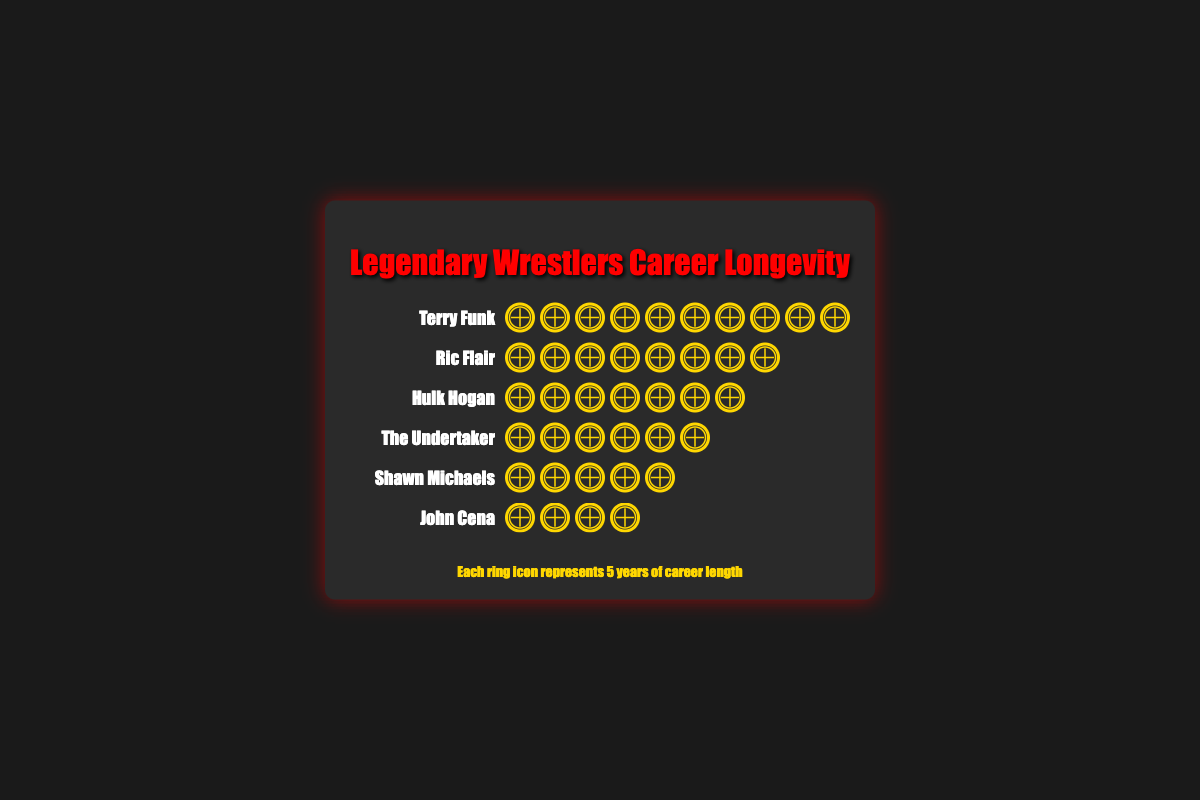Which wrestler has the longest career according to the figure? Terry Funk is represented by 10 rings, each representing 5 years, totaling 50 years.
Answer: Terry Funk How many more years did Ric Flair wrestle compared to John Cena? Ric Flair is represented by 8 rings (8 * 5 = 40 years) and John Cena is represented by 4 rings (4 * 5 = 20 years). The difference is 40 - 20 = 20 years.
Answer: 20 years Which two wrestlers have an equal number of ring icons? Ric Flair and Hulk Hogan both have 8 and 7 ring icons respectively, which are not equal. Shawn Michaels and The Undertaker both have 5 ring icons.
Answer: Shawn Michaels and The Undertaker What is the combined career length of Ric Flair and Shawn Michaels? Ric Flair is represented by 8 rings (8 * 5 = 40 years) and Shawn Michaels is represented by 5 rings (5 * 5 = 25 years). The combined career length is 40 + 25 = 65 years.
Answer: 65 years How many ring icons separate the wrestler with the longest career from the one with the shortest career? Terry Funk has 10 ring icons and John Cena has 4 ring icons. The difference is 10 - 4 = 6 ring icons.
Answer: 6 ring icons Which wrestler had a career length of 30 years? The Undertaker is represented by 6 rings, each representing 5 years, totaling 30 years.
Answer: The Undertaker How does the career longevity of Hulk Hogan compare to that of John Cena? Hulk Hogan is represented by 7 rings (7 * 5 = 35 years), and John Cena is represented by 4 rings (4 * 5 = 20 years). Therefore, Hulk Hogan wrestled for 35 - 20 = 15 more years than John Cena.
Answer: 15 years more If each ring represents 5 years, how many total years of career length are represented in the plot? Summing each wrestler's career length: Terry Funk (50), Ric Flair (40), Hulk Hogan (35), The Undertaker (30), Shawn Michaels (25), and John Cena (20) results in 50 + 40 + 35 + 30 + 25 + 20 = 200 years.
Answer: 200 years 